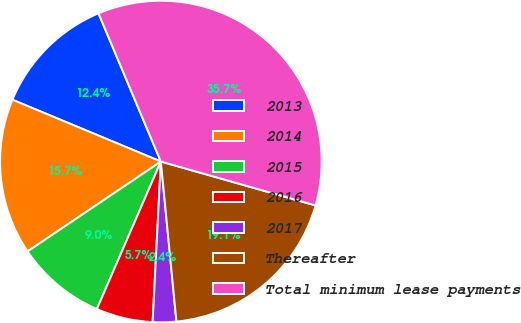Convert chart to OTSL. <chart><loc_0><loc_0><loc_500><loc_500><pie_chart><fcel>2013<fcel>2014<fcel>2015<fcel>2016<fcel>2017<fcel>Thereafter<fcel>Total minimum lease payments<nl><fcel>12.38%<fcel>15.72%<fcel>9.04%<fcel>5.7%<fcel>2.36%<fcel>19.05%<fcel>35.74%<nl></chart> 